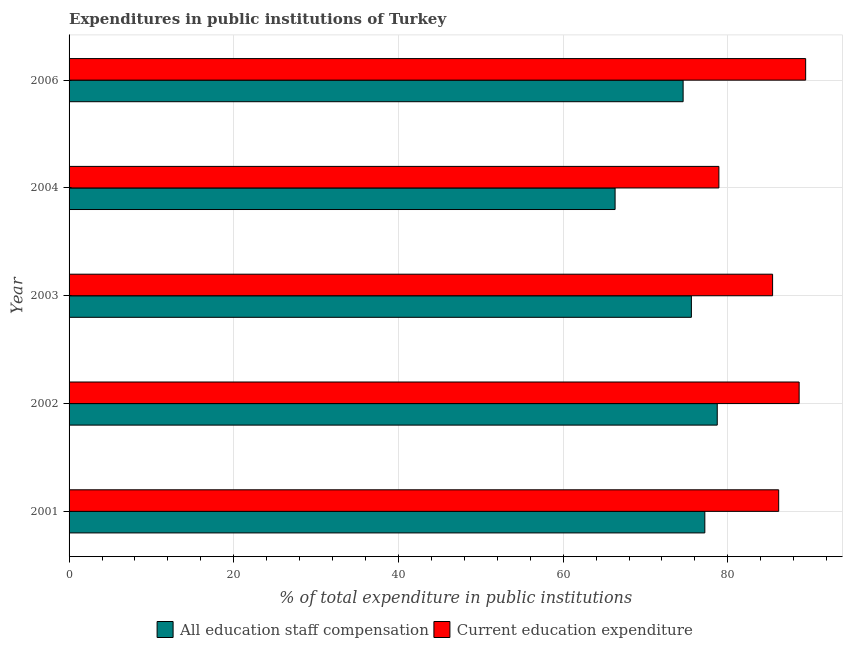How many groups of bars are there?
Offer a terse response. 5. Are the number of bars on each tick of the Y-axis equal?
Give a very brief answer. Yes. How many bars are there on the 1st tick from the bottom?
Provide a succinct answer. 2. In how many cases, is the number of bars for a given year not equal to the number of legend labels?
Keep it short and to the point. 0. What is the expenditure in education in 2002?
Your answer should be compact. 88.66. Across all years, what is the maximum expenditure in staff compensation?
Provide a succinct answer. 78.71. Across all years, what is the minimum expenditure in education?
Offer a very short reply. 78.91. In which year was the expenditure in education maximum?
Provide a short and direct response. 2006. What is the total expenditure in education in the graph?
Offer a very short reply. 428.61. What is the difference between the expenditure in staff compensation in 2002 and that in 2004?
Your answer should be compact. 12.41. What is the difference between the expenditure in education in 2002 and the expenditure in staff compensation in 2003?
Give a very brief answer. 13.08. What is the average expenditure in education per year?
Provide a succinct answer. 85.72. In the year 2006, what is the difference between the expenditure in education and expenditure in staff compensation?
Provide a short and direct response. 14.88. In how many years, is the expenditure in education greater than 4 %?
Your answer should be very brief. 5. What is the ratio of the expenditure in staff compensation in 2001 to that in 2006?
Offer a very short reply. 1.03. Is the expenditure in education in 2001 less than that in 2002?
Your answer should be very brief. Yes. Is the difference between the expenditure in education in 2001 and 2004 greater than the difference between the expenditure in staff compensation in 2001 and 2004?
Your answer should be very brief. No. What is the difference between the highest and the second highest expenditure in education?
Your response must be concise. 0.79. What is the difference between the highest and the lowest expenditure in staff compensation?
Provide a short and direct response. 12.41. Is the sum of the expenditure in staff compensation in 2003 and 2004 greater than the maximum expenditure in education across all years?
Offer a terse response. Yes. What does the 2nd bar from the top in 2004 represents?
Keep it short and to the point. All education staff compensation. What does the 1st bar from the bottom in 2004 represents?
Keep it short and to the point. All education staff compensation. Does the graph contain any zero values?
Your answer should be compact. No. Does the graph contain grids?
Your answer should be compact. Yes. Where does the legend appear in the graph?
Your response must be concise. Bottom center. How many legend labels are there?
Ensure brevity in your answer.  2. What is the title of the graph?
Provide a short and direct response. Expenditures in public institutions of Turkey. What is the label or title of the X-axis?
Provide a succinct answer. % of total expenditure in public institutions. What is the label or title of the Y-axis?
Offer a very short reply. Year. What is the % of total expenditure in public institutions in All education staff compensation in 2001?
Ensure brevity in your answer.  77.2. What is the % of total expenditure in public institutions of Current education expenditure in 2001?
Provide a short and direct response. 86.17. What is the % of total expenditure in public institutions in All education staff compensation in 2002?
Your answer should be very brief. 78.71. What is the % of total expenditure in public institutions in Current education expenditure in 2002?
Ensure brevity in your answer.  88.66. What is the % of total expenditure in public institutions of All education staff compensation in 2003?
Provide a succinct answer. 75.57. What is the % of total expenditure in public institutions of Current education expenditure in 2003?
Provide a succinct answer. 85.43. What is the % of total expenditure in public institutions of All education staff compensation in 2004?
Provide a succinct answer. 66.3. What is the % of total expenditure in public institutions of Current education expenditure in 2004?
Give a very brief answer. 78.91. What is the % of total expenditure in public institutions of All education staff compensation in 2006?
Offer a very short reply. 74.57. What is the % of total expenditure in public institutions of Current education expenditure in 2006?
Give a very brief answer. 89.45. Across all years, what is the maximum % of total expenditure in public institutions of All education staff compensation?
Provide a succinct answer. 78.71. Across all years, what is the maximum % of total expenditure in public institutions of Current education expenditure?
Offer a terse response. 89.45. Across all years, what is the minimum % of total expenditure in public institutions in All education staff compensation?
Offer a very short reply. 66.3. Across all years, what is the minimum % of total expenditure in public institutions of Current education expenditure?
Provide a succinct answer. 78.91. What is the total % of total expenditure in public institutions in All education staff compensation in the graph?
Make the answer very short. 372.35. What is the total % of total expenditure in public institutions in Current education expenditure in the graph?
Ensure brevity in your answer.  428.61. What is the difference between the % of total expenditure in public institutions in All education staff compensation in 2001 and that in 2002?
Your answer should be very brief. -1.51. What is the difference between the % of total expenditure in public institutions of Current education expenditure in 2001 and that in 2002?
Your response must be concise. -2.48. What is the difference between the % of total expenditure in public institutions in All education staff compensation in 2001 and that in 2003?
Provide a short and direct response. 1.63. What is the difference between the % of total expenditure in public institutions in Current education expenditure in 2001 and that in 2003?
Offer a terse response. 0.74. What is the difference between the % of total expenditure in public institutions of All education staff compensation in 2001 and that in 2004?
Your response must be concise. 10.9. What is the difference between the % of total expenditure in public institutions of Current education expenditure in 2001 and that in 2004?
Provide a succinct answer. 7.26. What is the difference between the % of total expenditure in public institutions in All education staff compensation in 2001 and that in 2006?
Provide a short and direct response. 2.64. What is the difference between the % of total expenditure in public institutions in Current education expenditure in 2001 and that in 2006?
Provide a succinct answer. -3.28. What is the difference between the % of total expenditure in public institutions of All education staff compensation in 2002 and that in 2003?
Give a very brief answer. 3.14. What is the difference between the % of total expenditure in public institutions in Current education expenditure in 2002 and that in 2003?
Your answer should be very brief. 3.22. What is the difference between the % of total expenditure in public institutions of All education staff compensation in 2002 and that in 2004?
Give a very brief answer. 12.41. What is the difference between the % of total expenditure in public institutions in Current education expenditure in 2002 and that in 2004?
Offer a very short reply. 9.75. What is the difference between the % of total expenditure in public institutions in All education staff compensation in 2002 and that in 2006?
Make the answer very short. 4.15. What is the difference between the % of total expenditure in public institutions in Current education expenditure in 2002 and that in 2006?
Ensure brevity in your answer.  -0.79. What is the difference between the % of total expenditure in public institutions in All education staff compensation in 2003 and that in 2004?
Ensure brevity in your answer.  9.27. What is the difference between the % of total expenditure in public institutions in Current education expenditure in 2003 and that in 2004?
Give a very brief answer. 6.52. What is the difference between the % of total expenditure in public institutions of Current education expenditure in 2003 and that in 2006?
Provide a succinct answer. -4.02. What is the difference between the % of total expenditure in public institutions in All education staff compensation in 2004 and that in 2006?
Ensure brevity in your answer.  -8.26. What is the difference between the % of total expenditure in public institutions of Current education expenditure in 2004 and that in 2006?
Offer a terse response. -10.54. What is the difference between the % of total expenditure in public institutions in All education staff compensation in 2001 and the % of total expenditure in public institutions in Current education expenditure in 2002?
Your response must be concise. -11.45. What is the difference between the % of total expenditure in public institutions of All education staff compensation in 2001 and the % of total expenditure in public institutions of Current education expenditure in 2003?
Make the answer very short. -8.23. What is the difference between the % of total expenditure in public institutions of All education staff compensation in 2001 and the % of total expenditure in public institutions of Current education expenditure in 2004?
Give a very brief answer. -1.71. What is the difference between the % of total expenditure in public institutions in All education staff compensation in 2001 and the % of total expenditure in public institutions in Current education expenditure in 2006?
Your answer should be very brief. -12.24. What is the difference between the % of total expenditure in public institutions in All education staff compensation in 2002 and the % of total expenditure in public institutions in Current education expenditure in 2003?
Offer a terse response. -6.72. What is the difference between the % of total expenditure in public institutions in All education staff compensation in 2002 and the % of total expenditure in public institutions in Current education expenditure in 2004?
Ensure brevity in your answer.  -0.2. What is the difference between the % of total expenditure in public institutions in All education staff compensation in 2002 and the % of total expenditure in public institutions in Current education expenditure in 2006?
Ensure brevity in your answer.  -10.74. What is the difference between the % of total expenditure in public institutions of All education staff compensation in 2003 and the % of total expenditure in public institutions of Current education expenditure in 2004?
Your response must be concise. -3.34. What is the difference between the % of total expenditure in public institutions of All education staff compensation in 2003 and the % of total expenditure in public institutions of Current education expenditure in 2006?
Provide a short and direct response. -13.88. What is the difference between the % of total expenditure in public institutions in All education staff compensation in 2004 and the % of total expenditure in public institutions in Current education expenditure in 2006?
Your response must be concise. -23.14. What is the average % of total expenditure in public institutions in All education staff compensation per year?
Your answer should be compact. 74.47. What is the average % of total expenditure in public institutions of Current education expenditure per year?
Provide a succinct answer. 85.72. In the year 2001, what is the difference between the % of total expenditure in public institutions in All education staff compensation and % of total expenditure in public institutions in Current education expenditure?
Your answer should be very brief. -8.97. In the year 2002, what is the difference between the % of total expenditure in public institutions of All education staff compensation and % of total expenditure in public institutions of Current education expenditure?
Make the answer very short. -9.94. In the year 2003, what is the difference between the % of total expenditure in public institutions of All education staff compensation and % of total expenditure in public institutions of Current education expenditure?
Offer a terse response. -9.86. In the year 2004, what is the difference between the % of total expenditure in public institutions of All education staff compensation and % of total expenditure in public institutions of Current education expenditure?
Provide a succinct answer. -12.6. In the year 2006, what is the difference between the % of total expenditure in public institutions of All education staff compensation and % of total expenditure in public institutions of Current education expenditure?
Provide a succinct answer. -14.88. What is the ratio of the % of total expenditure in public institutions in All education staff compensation in 2001 to that in 2002?
Your response must be concise. 0.98. What is the ratio of the % of total expenditure in public institutions in Current education expenditure in 2001 to that in 2002?
Make the answer very short. 0.97. What is the ratio of the % of total expenditure in public institutions in All education staff compensation in 2001 to that in 2003?
Keep it short and to the point. 1.02. What is the ratio of the % of total expenditure in public institutions in Current education expenditure in 2001 to that in 2003?
Your response must be concise. 1.01. What is the ratio of the % of total expenditure in public institutions of All education staff compensation in 2001 to that in 2004?
Your response must be concise. 1.16. What is the ratio of the % of total expenditure in public institutions of Current education expenditure in 2001 to that in 2004?
Provide a short and direct response. 1.09. What is the ratio of the % of total expenditure in public institutions in All education staff compensation in 2001 to that in 2006?
Your answer should be compact. 1.04. What is the ratio of the % of total expenditure in public institutions of Current education expenditure in 2001 to that in 2006?
Offer a terse response. 0.96. What is the ratio of the % of total expenditure in public institutions of All education staff compensation in 2002 to that in 2003?
Offer a terse response. 1.04. What is the ratio of the % of total expenditure in public institutions of Current education expenditure in 2002 to that in 2003?
Provide a succinct answer. 1.04. What is the ratio of the % of total expenditure in public institutions in All education staff compensation in 2002 to that in 2004?
Your answer should be compact. 1.19. What is the ratio of the % of total expenditure in public institutions in Current education expenditure in 2002 to that in 2004?
Offer a terse response. 1.12. What is the ratio of the % of total expenditure in public institutions in All education staff compensation in 2002 to that in 2006?
Your answer should be very brief. 1.06. What is the ratio of the % of total expenditure in public institutions of Current education expenditure in 2002 to that in 2006?
Your answer should be very brief. 0.99. What is the ratio of the % of total expenditure in public institutions in All education staff compensation in 2003 to that in 2004?
Offer a very short reply. 1.14. What is the ratio of the % of total expenditure in public institutions of Current education expenditure in 2003 to that in 2004?
Give a very brief answer. 1.08. What is the ratio of the % of total expenditure in public institutions in All education staff compensation in 2003 to that in 2006?
Keep it short and to the point. 1.01. What is the ratio of the % of total expenditure in public institutions of Current education expenditure in 2003 to that in 2006?
Provide a succinct answer. 0.96. What is the ratio of the % of total expenditure in public institutions in All education staff compensation in 2004 to that in 2006?
Provide a short and direct response. 0.89. What is the ratio of the % of total expenditure in public institutions in Current education expenditure in 2004 to that in 2006?
Offer a terse response. 0.88. What is the difference between the highest and the second highest % of total expenditure in public institutions of All education staff compensation?
Offer a terse response. 1.51. What is the difference between the highest and the second highest % of total expenditure in public institutions of Current education expenditure?
Offer a terse response. 0.79. What is the difference between the highest and the lowest % of total expenditure in public institutions of All education staff compensation?
Your answer should be very brief. 12.41. What is the difference between the highest and the lowest % of total expenditure in public institutions in Current education expenditure?
Offer a very short reply. 10.54. 